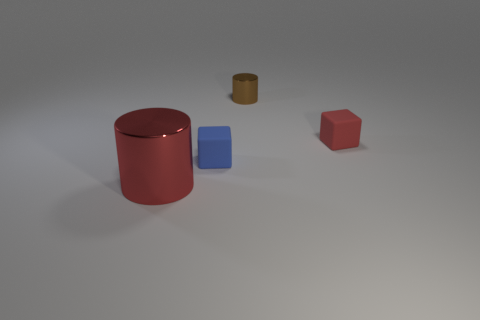Add 2 small blue cubes. How many objects exist? 6 Subtract all purple cylinders. Subtract all blue cubes. How many cylinders are left? 2 Subtract all red cylinders. How many cylinders are left? 1 Subtract all large red shiny cylinders. Subtract all purple matte objects. How many objects are left? 3 Add 3 tiny brown metal objects. How many tiny brown metal objects are left? 4 Add 1 big blue shiny objects. How many big blue shiny objects exist? 1 Subtract 0 green cylinders. How many objects are left? 4 